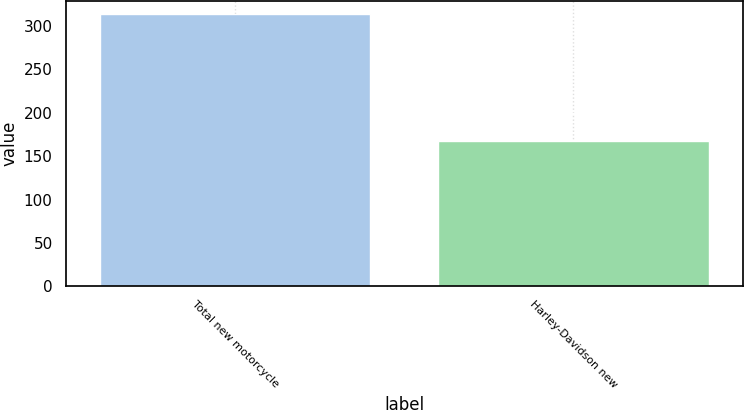Convert chart. <chart><loc_0><loc_0><loc_500><loc_500><bar_chart><fcel>Total new motorcycle<fcel>Harley-Davidson new<nl><fcel>313.6<fcel>167.1<nl></chart> 